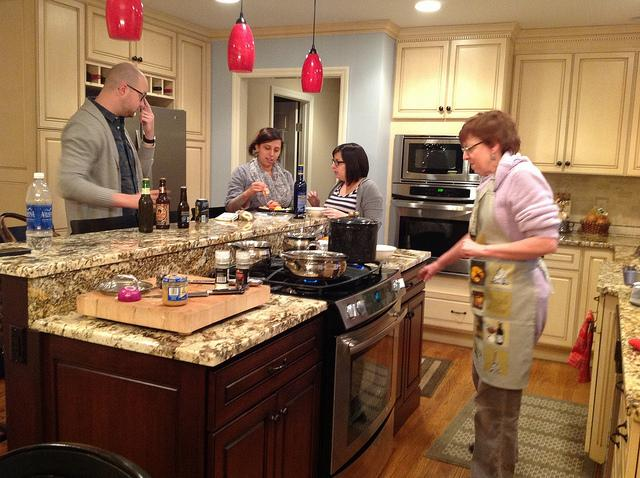What type of energy is being used by the stove? gas 